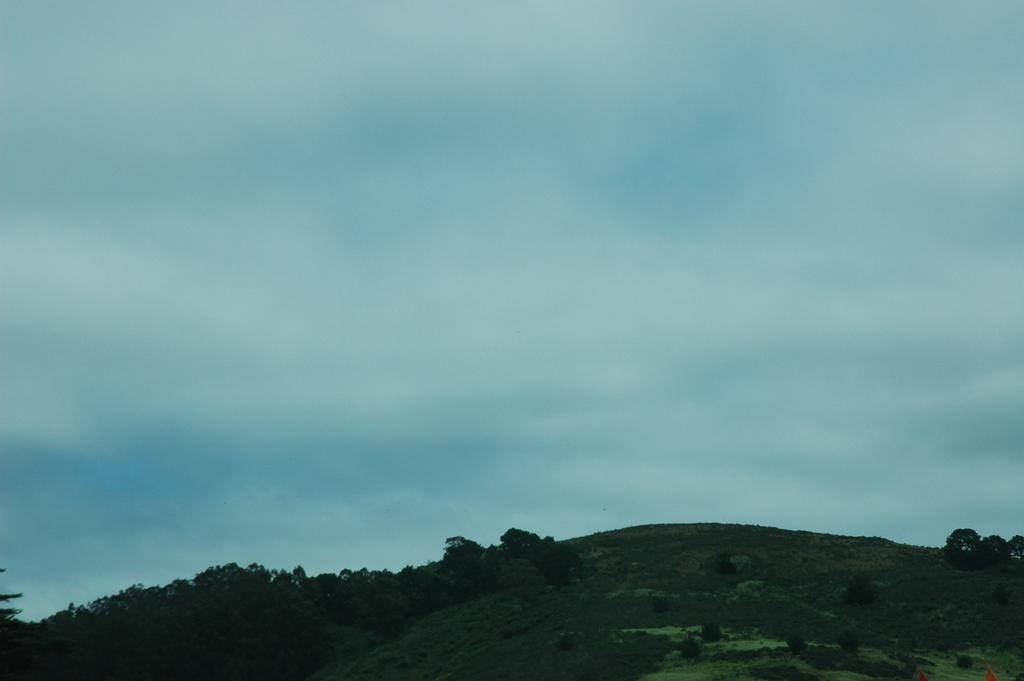What geographical feature is the main subject of the image? There is a hill in the image. What types of vegetation can be seen on the hill? The hill has plants and trees. What can be seen in the background of the image? There is a sky visible in the background of the image. What is the weather like in the image? Clouds are present in the sky, suggesting a partly cloudy day. What type of apparatus is being used to write on the hill in the image? There is no apparatus or writing present on the hill in the image. How does the hill contribute to the trip in the image? The hill is not part of a trip or journey in the image; it is a stationary geographical feature. 